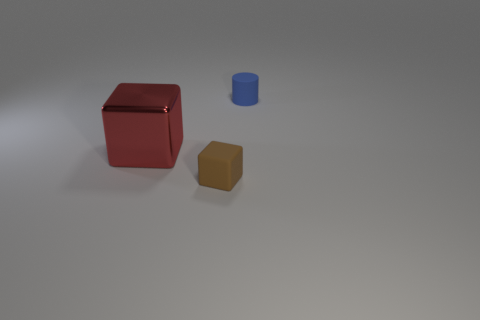Is there anything else that is the same shape as the small blue matte object?
Provide a short and direct response. No. Are there any other things that are the same size as the shiny cube?
Provide a short and direct response. No. There is a large red metal thing; what number of rubber things are behind it?
Offer a very short reply. 1. Does the small cube have the same material as the cylinder that is behind the metallic cube?
Offer a terse response. Yes. There is a block that is the same material as the tiny blue thing; what is its size?
Provide a succinct answer. Small. Are there more things that are behind the large red shiny object than matte blocks behind the tiny blue matte cylinder?
Your answer should be very brief. Yes. Are there any other shiny things that have the same shape as the brown thing?
Provide a short and direct response. Yes. There is a thing in front of the red metallic cube; does it have the same size as the blue object?
Your response must be concise. Yes. Are any matte cubes visible?
Your response must be concise. Yes. What number of objects are rubber things that are to the right of the tiny brown object or gray matte balls?
Provide a short and direct response. 1. 